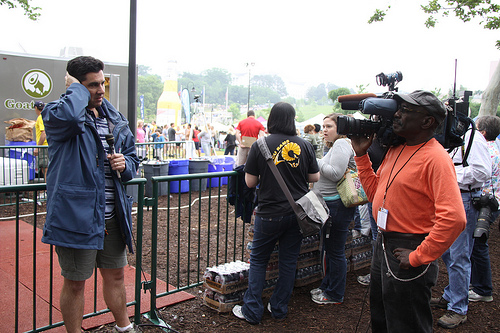<image>
Can you confirm if the identity card is on the man? Yes. Looking at the image, I can see the identity card is positioned on top of the man, with the man providing support. Where is the sky in relation to the pillar? Is it behind the pillar? Yes. From this viewpoint, the sky is positioned behind the pillar, with the pillar partially or fully occluding the sky. Is the fence in front of the man? No. The fence is not in front of the man. The spatial positioning shows a different relationship between these objects. 